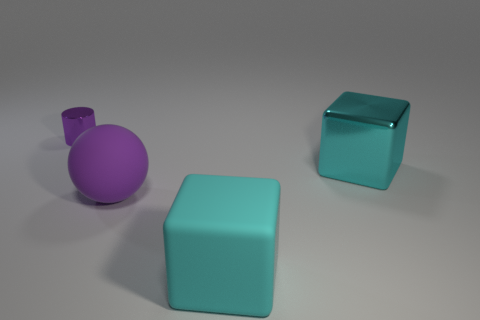There is another cube that is the same color as the big shiny cube; what size is it?
Provide a succinct answer. Large. Does the metallic object that is to the right of the metal cylinder have the same shape as the shiny thing left of the big cyan shiny thing?
Your answer should be very brief. No. What number of cyan rubber things are on the right side of the big purple rubber thing?
Offer a very short reply. 1. Do the purple object that is in front of the big metal cube and the purple cylinder have the same material?
Offer a terse response. No. What is the color of the rubber thing that is the same shape as the large cyan metallic thing?
Ensure brevity in your answer.  Cyan. What shape is the small metal object?
Make the answer very short. Cylinder. What number of things are either large purple metal spheres or big purple matte things?
Provide a succinct answer. 1. There is a metallic object that is on the right side of the purple cylinder; does it have the same color as the large rubber object in front of the big ball?
Offer a terse response. Yes. How many other objects are there of the same shape as the cyan metallic thing?
Ensure brevity in your answer.  1. Is there a small purple object?
Offer a very short reply. Yes. 